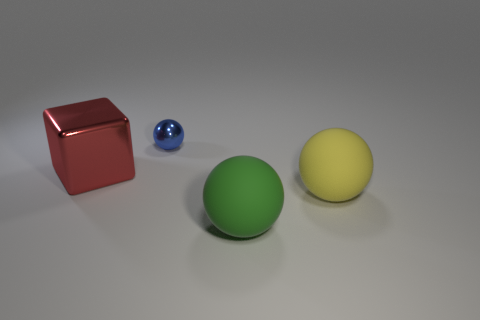What number of objects are on the left side of the big green matte object and to the right of the red thing?
Give a very brief answer. 1. What material is the sphere that is to the right of the green rubber ball?
Provide a succinct answer. Rubber. How many other cubes have the same color as the shiny cube?
Offer a terse response. 0. What is the size of the other object that is the same material as the green object?
Provide a succinct answer. Large. How many objects are tiny gray spheres or large blocks?
Provide a short and direct response. 1. What is the color of the metallic object that is on the left side of the blue metallic ball?
Your answer should be very brief. Red. The green thing that is the same shape as the tiny blue thing is what size?
Make the answer very short. Large. What number of objects are big objects right of the tiny blue ball or big things that are on the left side of the tiny ball?
Provide a succinct answer. 3. What is the size of the ball that is both behind the big green sphere and in front of the blue thing?
Keep it short and to the point. Large. Is the shape of the big shiny thing the same as the large matte object that is behind the big green rubber ball?
Give a very brief answer. No. 